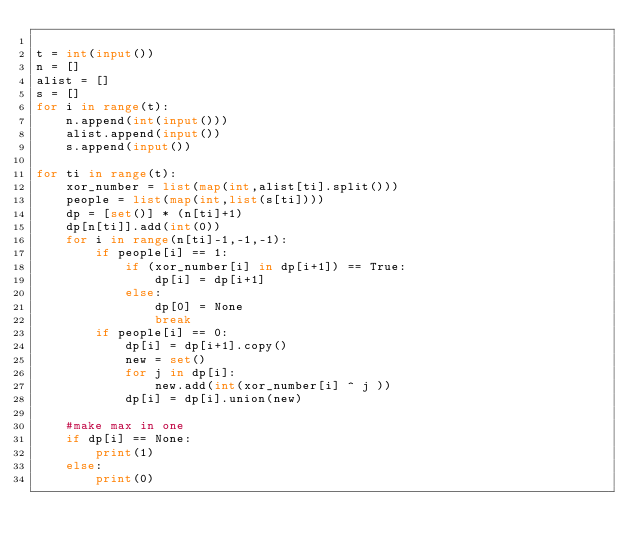<code> <loc_0><loc_0><loc_500><loc_500><_Python_>
t = int(input())
n = []
alist = []
s = []
for i in range(t):
    n.append(int(input()))
    alist.append(input())
    s.append(input())

for ti in range(t):
    xor_number = list(map(int,alist[ti].split()))
    people = list(map(int,list(s[ti])))
    dp = [set()] * (n[ti]+1)
    dp[n[ti]].add(int(0))
    for i in range(n[ti]-1,-1,-1):
        if people[i] == 1:
            if (xor_number[i] in dp[i+1]) == True:
                dp[i] = dp[i+1]
            else:
                dp[0] = None
                break
        if people[i] == 0:
            dp[i] = dp[i+1].copy()
            new = set()
            for j in dp[i]:
                new.add(int(xor_number[i] ^ j ))    
            dp[i] = dp[i].union(new)
    
    #make max in one
    if dp[i] == None:
        print(1)
    else: 
        print(0)
</code> 